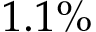Convert formula to latex. <formula><loc_0><loc_0><loc_500><loc_500>1 . 1 \%</formula> 